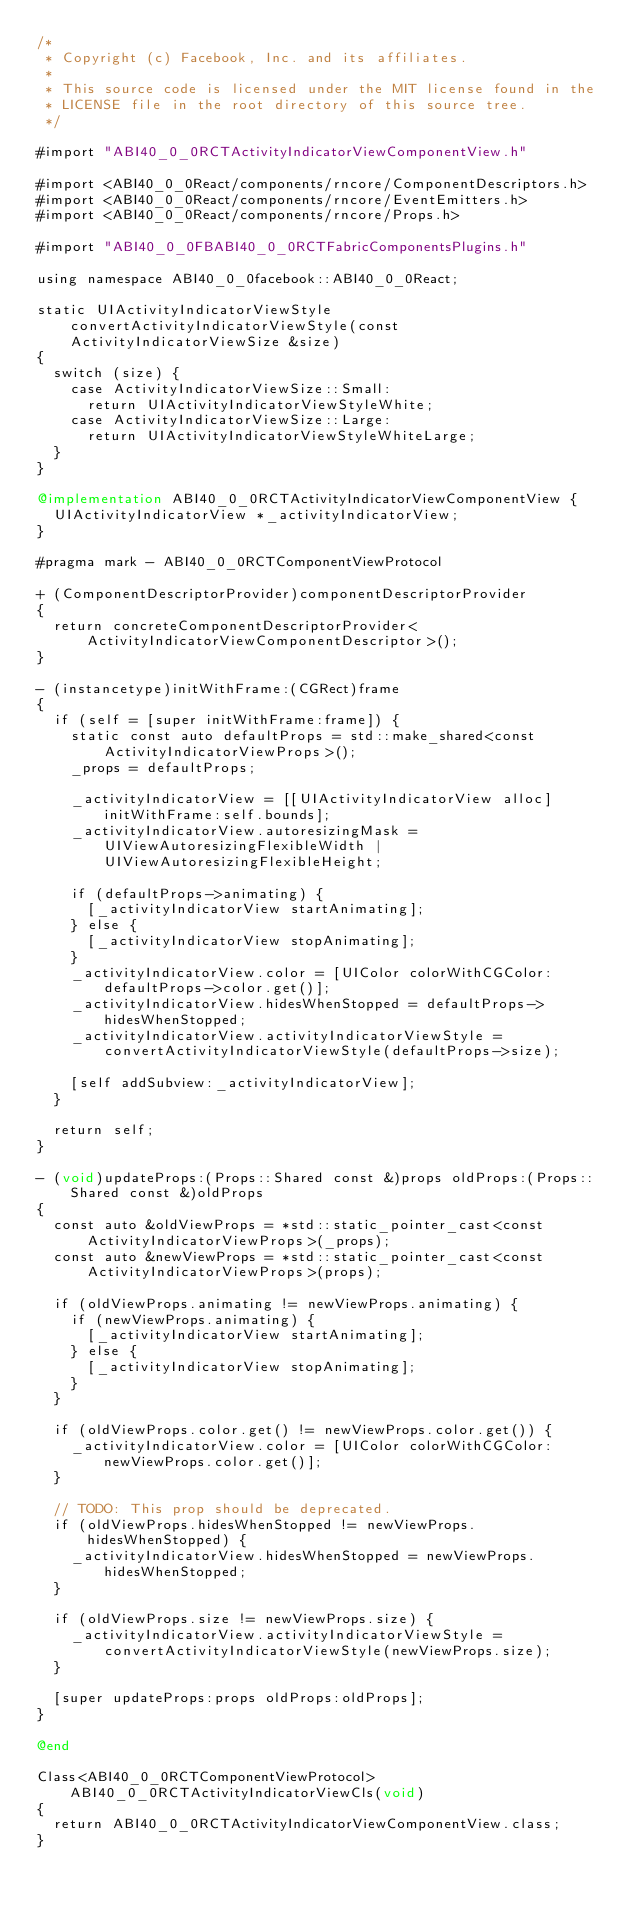<code> <loc_0><loc_0><loc_500><loc_500><_ObjectiveC_>/*
 * Copyright (c) Facebook, Inc. and its affiliates.
 *
 * This source code is licensed under the MIT license found in the
 * LICENSE file in the root directory of this source tree.
 */

#import "ABI40_0_0RCTActivityIndicatorViewComponentView.h"

#import <ABI40_0_0React/components/rncore/ComponentDescriptors.h>
#import <ABI40_0_0React/components/rncore/EventEmitters.h>
#import <ABI40_0_0React/components/rncore/Props.h>

#import "ABI40_0_0FBABI40_0_0RCTFabricComponentsPlugins.h"

using namespace ABI40_0_0facebook::ABI40_0_0React;

static UIActivityIndicatorViewStyle convertActivityIndicatorViewStyle(const ActivityIndicatorViewSize &size)
{
  switch (size) {
    case ActivityIndicatorViewSize::Small:
      return UIActivityIndicatorViewStyleWhite;
    case ActivityIndicatorViewSize::Large:
      return UIActivityIndicatorViewStyleWhiteLarge;
  }
}

@implementation ABI40_0_0RCTActivityIndicatorViewComponentView {
  UIActivityIndicatorView *_activityIndicatorView;
}

#pragma mark - ABI40_0_0RCTComponentViewProtocol

+ (ComponentDescriptorProvider)componentDescriptorProvider
{
  return concreteComponentDescriptorProvider<ActivityIndicatorViewComponentDescriptor>();
}

- (instancetype)initWithFrame:(CGRect)frame
{
  if (self = [super initWithFrame:frame]) {
    static const auto defaultProps = std::make_shared<const ActivityIndicatorViewProps>();
    _props = defaultProps;

    _activityIndicatorView = [[UIActivityIndicatorView alloc] initWithFrame:self.bounds];
    _activityIndicatorView.autoresizingMask = UIViewAutoresizingFlexibleWidth | UIViewAutoresizingFlexibleHeight;

    if (defaultProps->animating) {
      [_activityIndicatorView startAnimating];
    } else {
      [_activityIndicatorView stopAnimating];
    }
    _activityIndicatorView.color = [UIColor colorWithCGColor:defaultProps->color.get()];
    _activityIndicatorView.hidesWhenStopped = defaultProps->hidesWhenStopped;
    _activityIndicatorView.activityIndicatorViewStyle = convertActivityIndicatorViewStyle(defaultProps->size);

    [self addSubview:_activityIndicatorView];
  }

  return self;
}

- (void)updateProps:(Props::Shared const &)props oldProps:(Props::Shared const &)oldProps
{
  const auto &oldViewProps = *std::static_pointer_cast<const ActivityIndicatorViewProps>(_props);
  const auto &newViewProps = *std::static_pointer_cast<const ActivityIndicatorViewProps>(props);

  if (oldViewProps.animating != newViewProps.animating) {
    if (newViewProps.animating) {
      [_activityIndicatorView startAnimating];
    } else {
      [_activityIndicatorView stopAnimating];
    }
  }

  if (oldViewProps.color.get() != newViewProps.color.get()) {
    _activityIndicatorView.color = [UIColor colorWithCGColor:newViewProps.color.get()];
  }

  // TODO: This prop should be deprecated.
  if (oldViewProps.hidesWhenStopped != newViewProps.hidesWhenStopped) {
    _activityIndicatorView.hidesWhenStopped = newViewProps.hidesWhenStopped;
  }

  if (oldViewProps.size != newViewProps.size) {
    _activityIndicatorView.activityIndicatorViewStyle = convertActivityIndicatorViewStyle(newViewProps.size);
  }

  [super updateProps:props oldProps:oldProps];
}

@end

Class<ABI40_0_0RCTComponentViewProtocol> ABI40_0_0RCTActivityIndicatorViewCls(void)
{
  return ABI40_0_0RCTActivityIndicatorViewComponentView.class;
}
</code> 